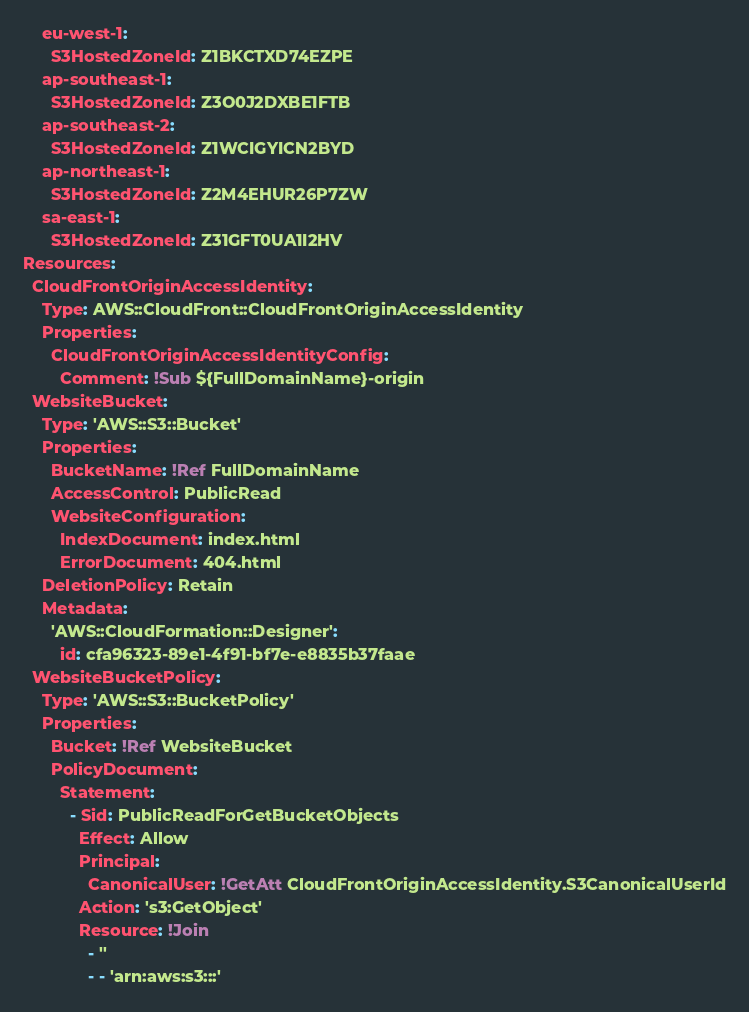Convert code to text. <code><loc_0><loc_0><loc_500><loc_500><_YAML_>    eu-west-1:
      S3HostedZoneId: Z1BKCTXD74EZPE
    ap-southeast-1:
      S3HostedZoneId: Z3O0J2DXBE1FTB
    ap-southeast-2:
      S3HostedZoneId: Z1WCIGYICN2BYD
    ap-northeast-1:
      S3HostedZoneId: Z2M4EHUR26P7ZW
    sa-east-1:
      S3HostedZoneId: Z31GFT0UA1I2HV
Resources:
  CloudFrontOriginAccessIdentity:
    Type: AWS::CloudFront::CloudFrontOriginAccessIdentity
    Properties:
      CloudFrontOriginAccessIdentityConfig:
        Comment: !Sub ${FullDomainName}-origin
  WebsiteBucket:
    Type: 'AWS::S3::Bucket'
    Properties:
      BucketName: !Ref FullDomainName
      AccessControl: PublicRead
      WebsiteConfiguration:
        IndexDocument: index.html
        ErrorDocument: 404.html
    DeletionPolicy: Retain
    Metadata:
      'AWS::CloudFormation::Designer':
        id: cfa96323-89e1-4f91-bf7e-e8835b37faae
  WebsiteBucketPolicy:
    Type: 'AWS::S3::BucketPolicy'
    Properties:
      Bucket: !Ref WebsiteBucket
      PolicyDocument:
        Statement:
          - Sid: PublicReadForGetBucketObjects
            Effect: Allow
            Principal: 
              CanonicalUser: !GetAtt CloudFrontOriginAccessIdentity.S3CanonicalUserId
            Action: 's3:GetObject'
            Resource: !Join 
              - ''
              - - 'arn:aws:s3:::'</code> 